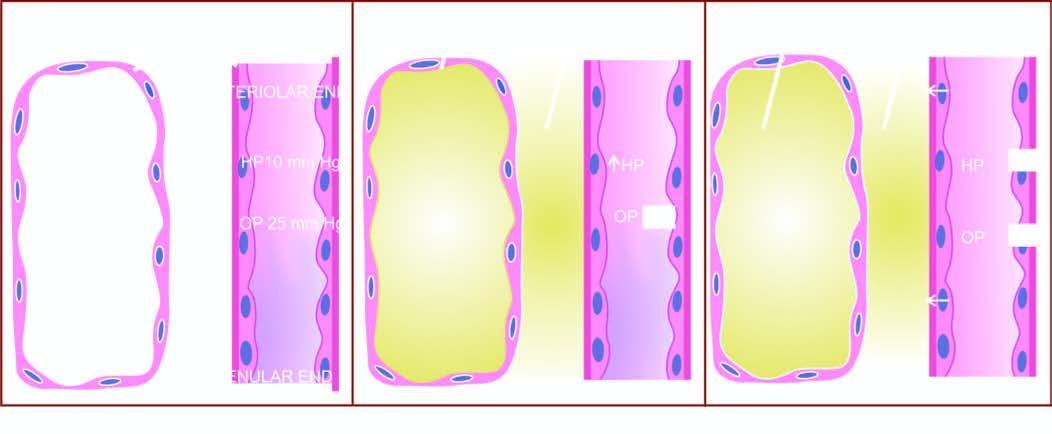what are mechanisms involved in?
Answer the question using a single word or phrase. The pathogenesis of cardiac oedema 